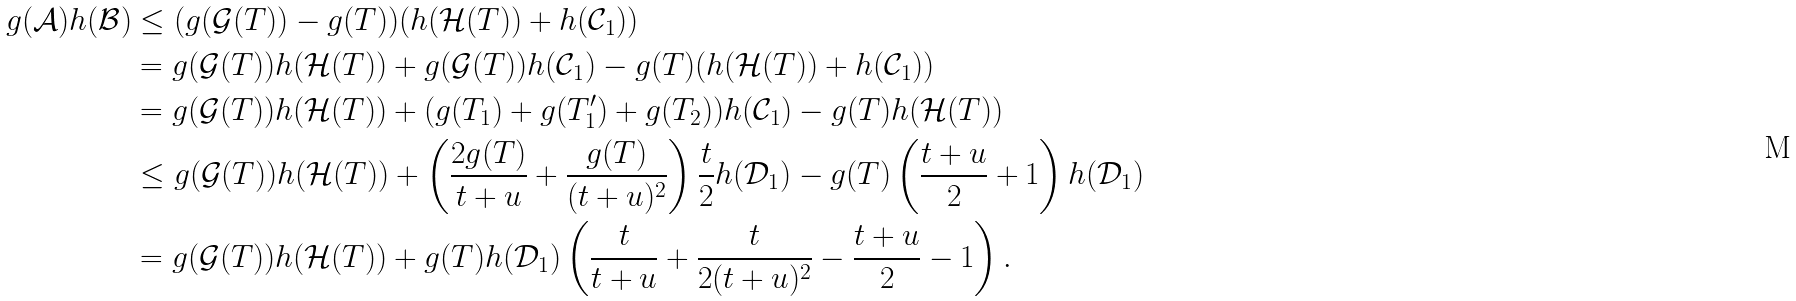<formula> <loc_0><loc_0><loc_500><loc_500>g ( \mathcal { A } ) h ( \mathcal { B } ) & \leq ( g ( \mathcal { G } ( T ) ) - g ( T ) ) ( h ( \mathcal { H } ( T ) ) + h ( \mathcal { C } _ { 1 } ) ) \\ & = g ( \mathcal { G } ( T ) ) h ( \mathcal { H } ( T ) ) + g ( \mathcal { G } ( T ) ) h ( \mathcal { C } _ { 1 } ) - g ( T ) ( h ( \mathcal { H } ( T ) ) + h ( \mathcal { C } _ { 1 } ) ) \\ & = g ( \mathcal { G } ( T ) ) h ( \mathcal { H } ( T ) ) + ( g ( T _ { 1 } ) + g ( T _ { 1 } ^ { \prime } ) + g ( T _ { 2 } ) ) h ( \mathcal { C } _ { 1 } ) - g ( T ) h ( \mathcal { H } ( T ) ) \\ & \leq g ( \mathcal { G } ( T ) ) h ( \mathcal { H } ( T ) ) + \left ( \frac { 2 g ( T ) } { t + u } + \frac { g ( T ) } { ( t + u ) ^ { 2 } } \right ) \frac { t } { 2 } h ( \mathcal { D } _ { 1 } ) - g ( T ) \left ( \frac { t + u } { 2 } + 1 \right ) h ( \mathcal { D } _ { 1 } ) \\ & = g ( \mathcal { G } ( T ) ) h ( \mathcal { H } ( T ) ) + g ( T ) h ( \mathcal { D } _ { 1 } ) \left ( \frac { t } { t + u } + \frac { t } { 2 ( t + u ) ^ { 2 } } - \frac { t + u } { 2 } - 1 \right ) .</formula> 